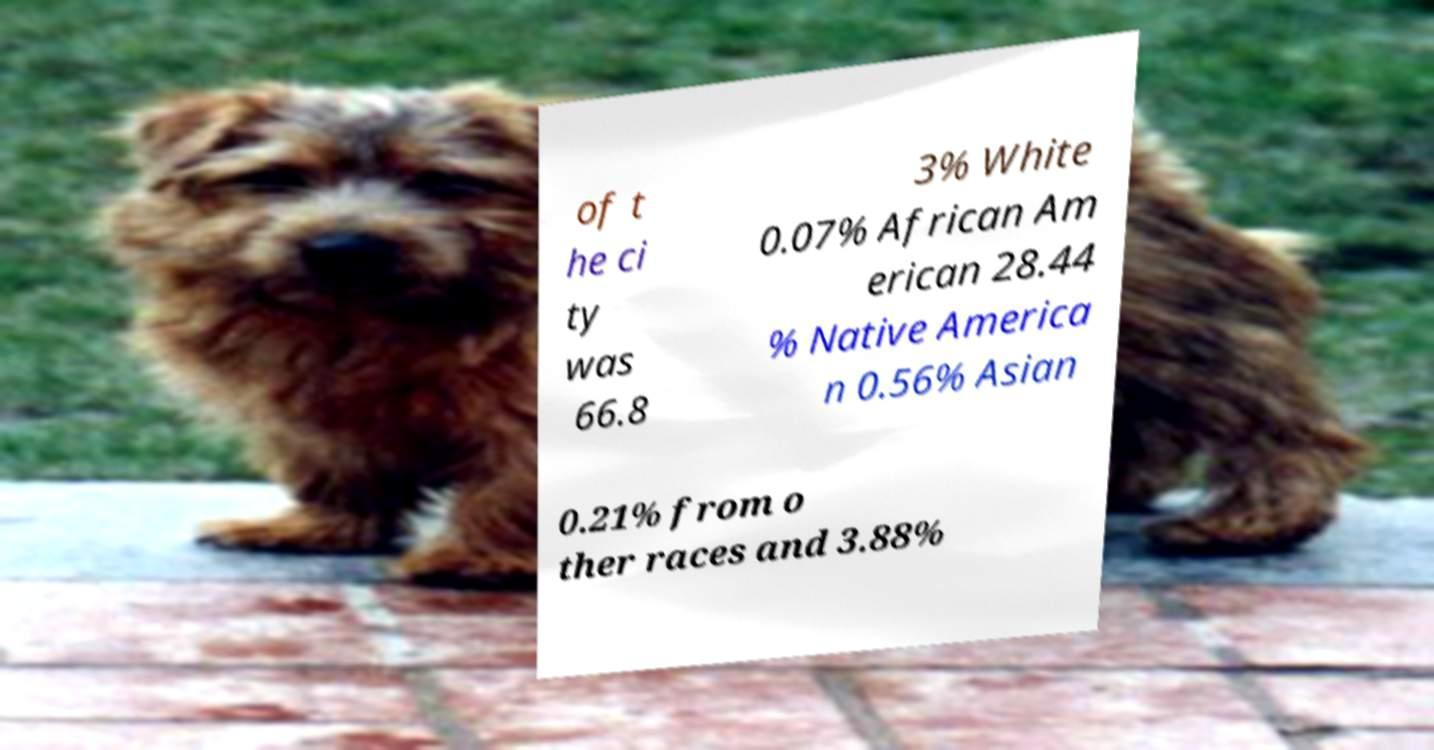There's text embedded in this image that I need extracted. Can you transcribe it verbatim? of t he ci ty was 66.8 3% White 0.07% African Am erican 28.44 % Native America n 0.56% Asian 0.21% from o ther races and 3.88% 